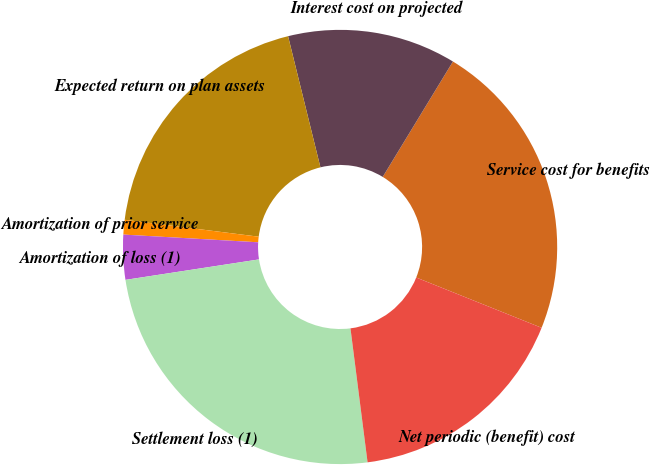Convert chart to OTSL. <chart><loc_0><loc_0><loc_500><loc_500><pie_chart><fcel>Service cost for benefits<fcel>Interest cost on projected<fcel>Expected return on plan assets<fcel>Amortization of prior service<fcel>Amortization of loss (1)<fcel>Settlement loss (1)<fcel>Net periodic (benefit) cost<nl><fcel>22.37%<fcel>12.55%<fcel>19.15%<fcel>1.09%<fcel>3.33%<fcel>24.6%<fcel>16.91%<nl></chart> 